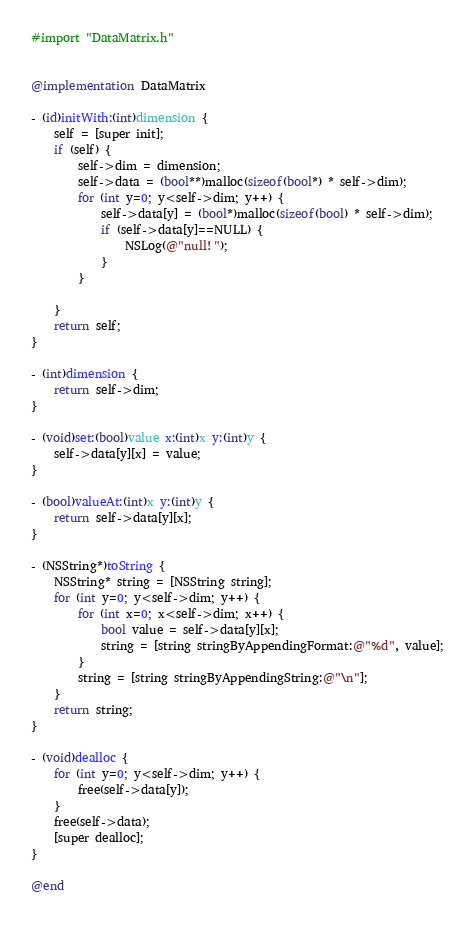<code> <loc_0><loc_0><loc_500><loc_500><_ObjectiveC_>

#import "DataMatrix.h"


@implementation DataMatrix

- (id)initWith:(int)dimension {
    self = [super init];
    if (self) {
        self->dim = dimension;
        self->data = (bool**)malloc(sizeof(bool*) * self->dim);
        for (int y=0; y<self->dim; y++) {
            self->data[y] = (bool*)malloc(sizeof(bool) * self->dim);
            if (self->data[y]==NULL) {
                NSLog(@"null!");
            }
        }
        
    }
    return self;
}

- (int)dimension {
    return self->dim;
}

- (void)set:(bool)value x:(int)x y:(int)y {
    self->data[y][x] = value;
}

- (bool)valueAt:(int)x y:(int)y {
    return self->data[y][x];
}

- (NSString*)toString {
    NSString* string = [NSString string];
    for (int y=0; y<self->dim; y++) {
        for (int x=0; x<self->dim; x++) {
            bool value = self->data[y][x];
            string = [string stringByAppendingFormat:@"%d", value];
        }
        string = [string stringByAppendingString:@"\n"];
    }
    return string;
}

- (void)dealloc {
    for (int y=0; y<self->dim; y++) {
        free(self->data[y]);
    }
    free(self->data);
    [super dealloc];
}

@end
</code> 